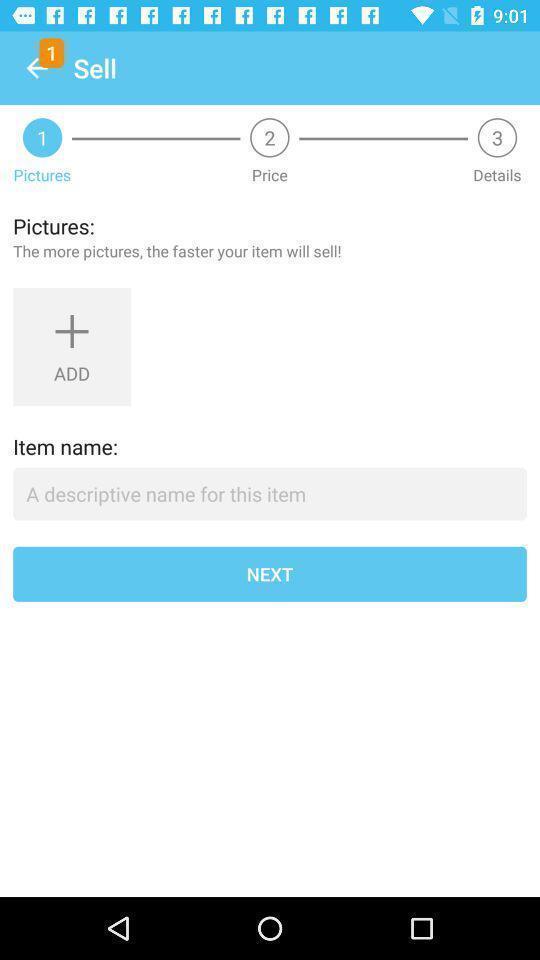Summarize the information in this screenshot. Screen displaying multiple options. 